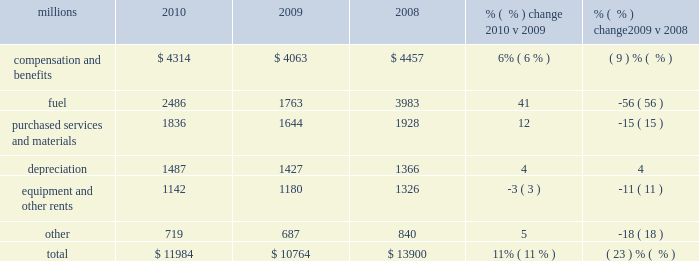Operating expenses millions 2010 2009 2008 % (  % ) change 2010 v 2009 % (  % ) change 2009 v 2008 .
Operating expenses increased $ 1.2 billion in 2010 versus 2009 .
Our fuel price per gallon increased 31% ( 31 % ) during the year , accounting for $ 566 million of the increase .
Wage and benefit inflation , depreciation , volume-related costs , and property taxes also contributed to higher expenses during 2010 compared to 2009 .
Cost savings from productivity improvements and better resource utilization partially offset these increases .
Operating expenses decreased $ 3.1 billion in 2009 versus 2008 .
Our fuel price per gallon declined 44% ( 44 % ) during 2009 , decreasing operating expenses by $ 1.3 billion compared to 2008 .
Cost savings from lower volume , productivity improvements , and better resource utilization also decreased operating expenses in 2009 .
In addition , lower casualty expense resulting primarily from improving trends in safety performance decreased operating expenses in 2009 .
Conversely , wage and benefit inflation partially offset these reductions .
Compensation and benefits 2013 compensation and benefits include wages , payroll taxes , health and welfare costs , pension costs , other postretirement benefits , and incentive costs .
General wage and benefit inflation increased costs by approximately $ 190 million in 2010 compared to 2009 .
Volume- related expenses and higher equity and incentive compensation also drove costs up during the year .
Workforce levels declined 1% ( 1 % ) in 2010 compared to 2009 as network efficiencies and ongoing productivity initiatives enabled us to effectively handle the 13% ( 13 % ) increase in volume levels with fewer employees .
Lower volume and productivity initiatives led to a 10% ( 10 % ) decline in our workforce in 2009 compared to 2008 , saving $ 516 million during the year .
Conversely , general wage and benefit inflation increased expenses , partially offsetting these savings .
Fuel 2013 fuel includes locomotive fuel and gasoline for highway and non-highway vehicles and heavy equipment .
Higher diesel fuel prices , which averaged $ 2.29 per gallon ( including taxes and transportation costs ) in 2010 compared to $ 1.75 per gallon in 2009 , increased expenses by $ 566 million .
Volume , as measured by gross ton-miles , increased 10% ( 10 % ) in 2010 versus 2009 , driving fuel expense up by $ 166 million .
Conversely , the use of newer , more fuel efficient locomotives , our fuel conservation programs and efficient network operations drove a 3% ( 3 % ) improvement in our fuel consumption rate in 2010 , resulting in $ 40 million of cost savings versus 2009 at the 2009 average fuel price .
Lower diesel fuel prices , which averaged $ 1.75 per gallon ( including taxes and transportation costs ) in 2009 compared to $ 3.15 per gallon in 2008 , reduced expenses by $ 1.3 billion in 2009 .
Volume , as measured by gross ton-miles , decreased 17% ( 17 % ) in 2009 , lowering expenses by $ 664 million compared to 2008 .
Our fuel consumption rate improved 4% ( 4 % ) in 2009 , resulting in $ 147 million of cost savings versus 2008 at the 2008 average fuel price .
The consumption rate savings versus 2008 using the lower 2009 fuel price was $ 68 million .
Newer , more fuel efficient locomotives , reflecting locomotive acquisitions in recent years and the impact of a smaller fleet due to storage of some of our older locomotives ; increased use of 2010 operating expenses .
What was the percentage increase for diesel fuel prices from 2009 to 2010? 
Computations: ((2.29 - 1.75) / 1.75)
Answer: 0.30857. 